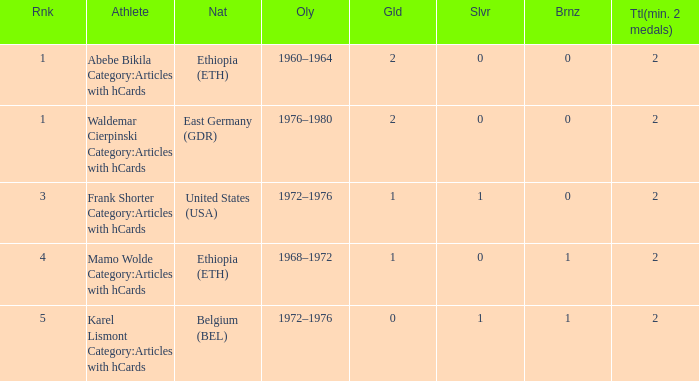What is the least amount of total medals won? 2.0. 